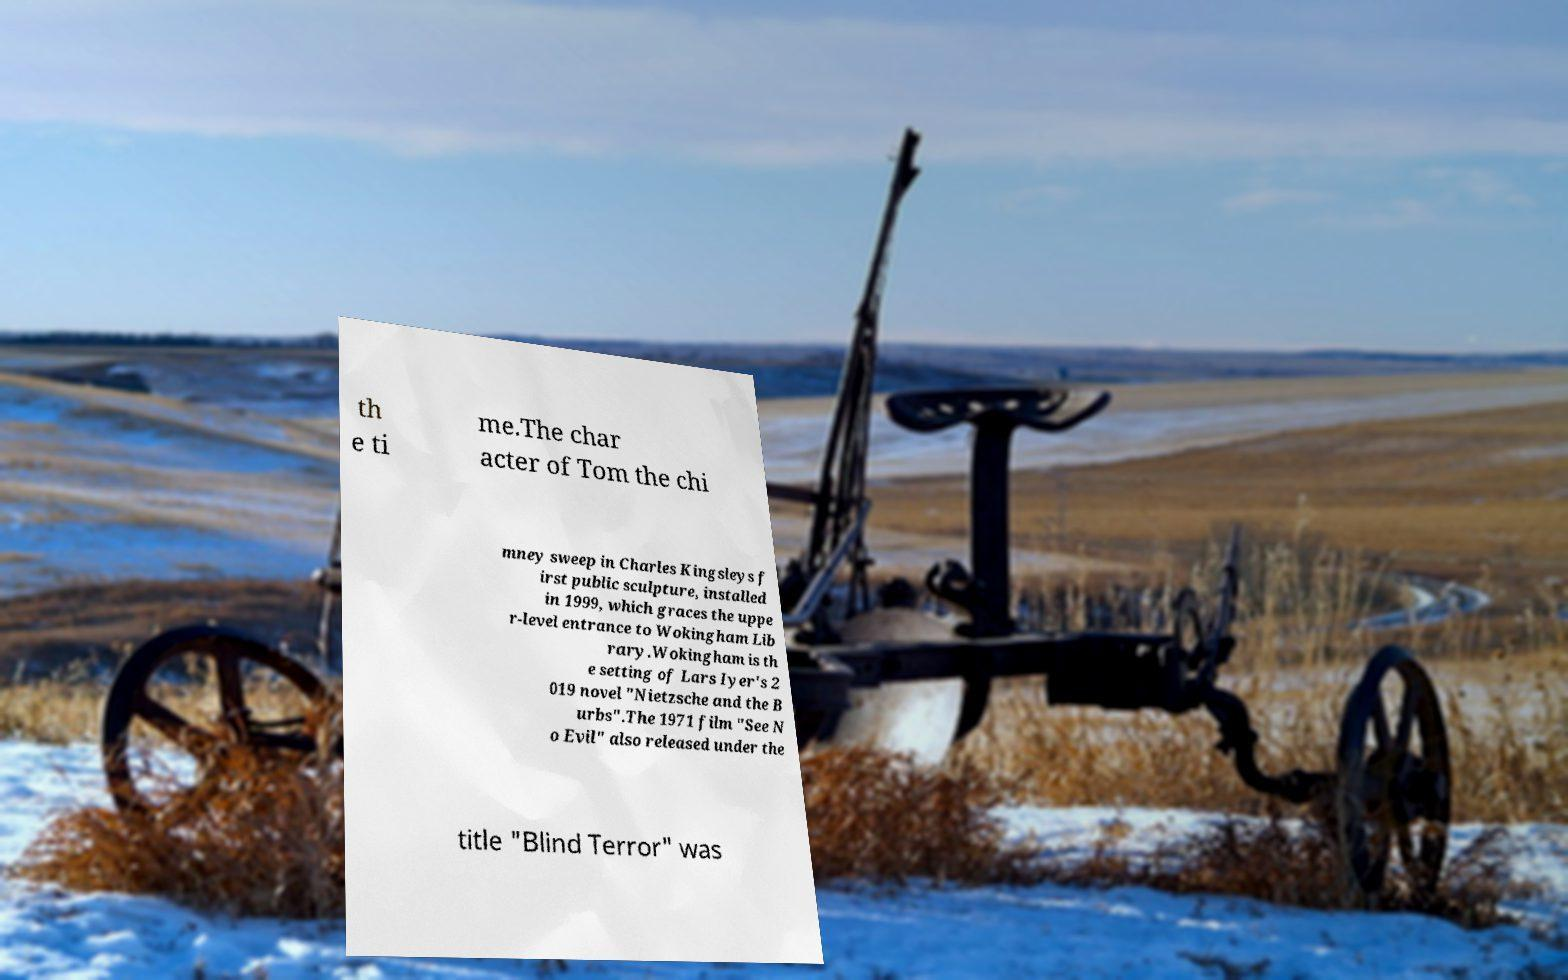Please identify and transcribe the text found in this image. th e ti me.The char acter of Tom the chi mney sweep in Charles Kingsleys f irst public sculpture, installed in 1999, which graces the uppe r-level entrance to Wokingham Lib rary.Wokingham is th e setting of Lars Iyer's 2 019 novel "Nietzsche and the B urbs".The 1971 film "See N o Evil" also released under the title "Blind Terror" was 